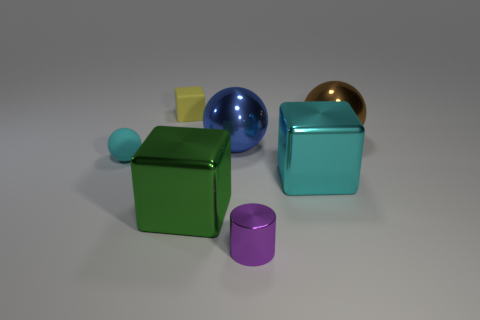Subtract all green metal cubes. How many cubes are left? 2 Subtract all blue balls. How many balls are left? 2 Subtract 1 cylinders. How many cylinders are left? 0 Subtract all tiny brown cubes. Subtract all small yellow matte objects. How many objects are left? 6 Add 1 big green cubes. How many big green cubes are left? 2 Add 1 blue spheres. How many blue spheres exist? 2 Add 3 big brown balls. How many objects exist? 10 Subtract 0 red cylinders. How many objects are left? 7 Subtract all spheres. How many objects are left? 4 Subtract all red blocks. Subtract all gray balls. How many blocks are left? 3 